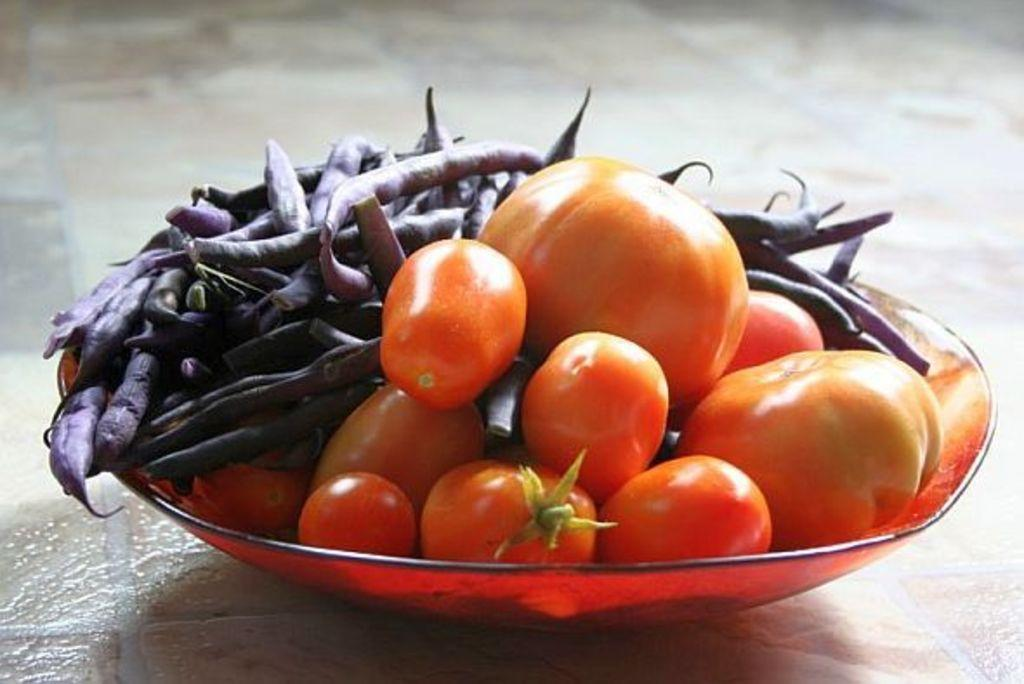What is in the bowl that is visible in the image? There is a bowl with tomatoes in the image. What else is in the bowl besides tomatoes? There are beans in the bowl. Where is the bowl located in the image? The bowl is placed on a platform. What type of laugh can be heard coming from the queen in the image? There is no queen or laughter present in the image; it features a bowl with tomatoes and beans on a platform. 